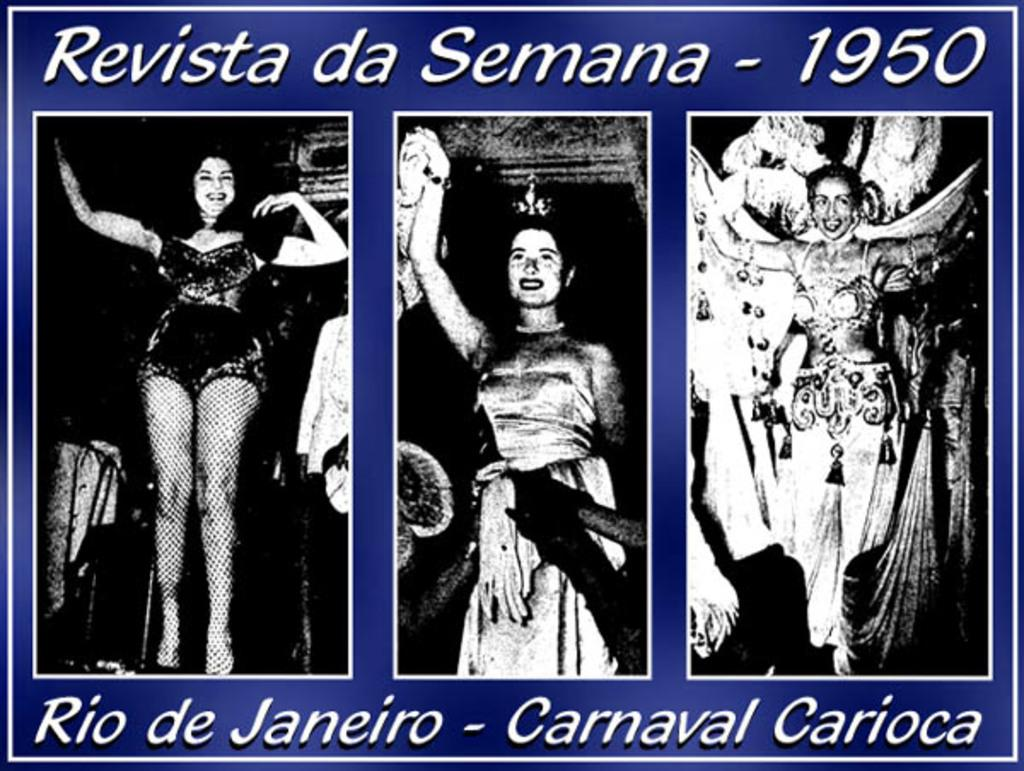What is the color scheme of the images? The images contain black and white images of ladies. What color is the background of the images? The background of the images is blue. Where can writing be found in the images? There is writing at the top and bottom of the image. How much dirt is visible on the ladies in the images? There is no dirt visible on the ladies in the images, as they are black and white images. What rules are being followed by the ladies in the images? There is no information about any rules being followed by the ladies in the images. 